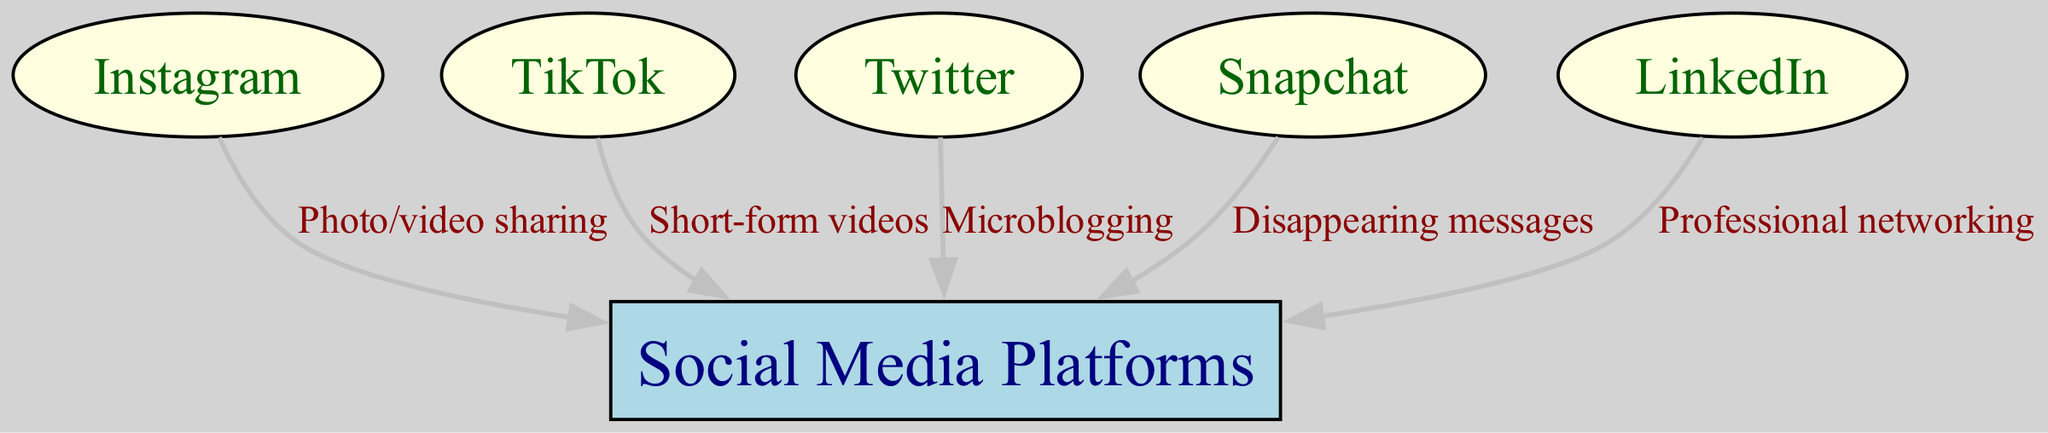What is the primary feature of Instagram? The diagram shows an edge from Instagram to Social Media Platforms, with the label "Photo/video sharing." This indicates that the main feature associated with Instagram, as depicted in the diagram, is the sharing of photos and videos.
Answer: Photo/video sharing How many nodes represent social media platforms in total? The diagram lists six distinct nodes, which include one main node for social media platforms and five other nodes for individual platforms (Instagram, TikTok, Twitter, Snapchat, and LinkedIn). Therefore, a careful count shows there are a total of six nodes.
Answer: 6 Which social media platform is linked with disappearing messages? The edge labeled "Disappearing messages" connects Snapchat to Social Media Platforms. By examining this connection, we see that the feature associated with Snapchat is the disappearing messages.
Answer: Snapchat What type of content does TikTok primarily focus on? The label on the edge from TikTok to Social Media Platforms reads "Short-form videos." This clearly points out that TikTok is primarily focused on short videos as its key content type.
Answer: Short-form videos Which platform is associated with professional networking? The edge from LinkedIn to Social Media Platforms is labeled "Professional networking." By examining this connection, we can determine that LinkedIn is specifically known for its professional networking feature.
Answer: LinkedIn What type of communication does Twitter facilitate? The label on the edge from Twitter to Social Media Platforms indicates "Microblogging." This defines Twitter's primary function as facilitating brief posts and updates from users.
Answer: Microblogging How many edges connect social media platforms to the main social media node? There are five edges shown in the diagram, each representing a different feature of the individual social media platforms that connect to the overarching node of Social Media Platforms. Therefore, the total number of edges is five.
Answer: 5 Which platform is highlighted for its unique feature of short messages? The diagram identifies Twitter with the feature of "Microblogging," which involves sharing short messages. Thus, we conclude that Twitter is highlighted in this context.
Answer: Twitter 